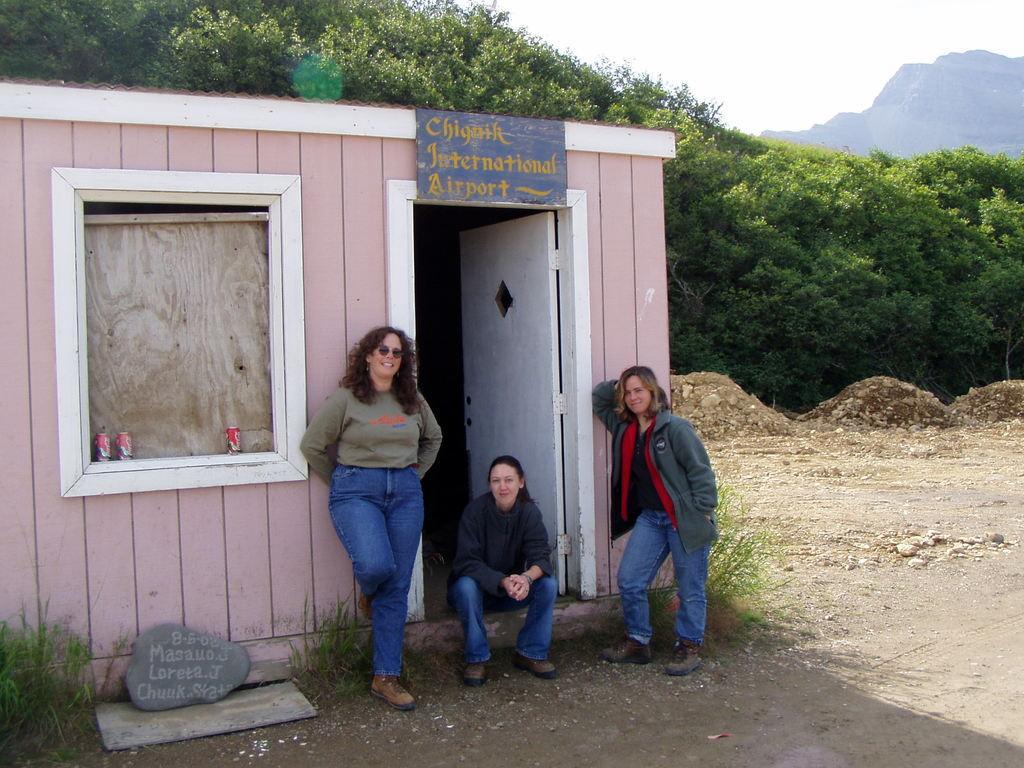Can you describe this image briefly? In this image I can see two women wearing jeans are standing and a woman wearing jeans and shoe is sitting. I can see a rock, some grass and a shed which is made of wooden logs. I can see few cool drink tins on the window. In the background I can see few trees, a mountain and the sky. 